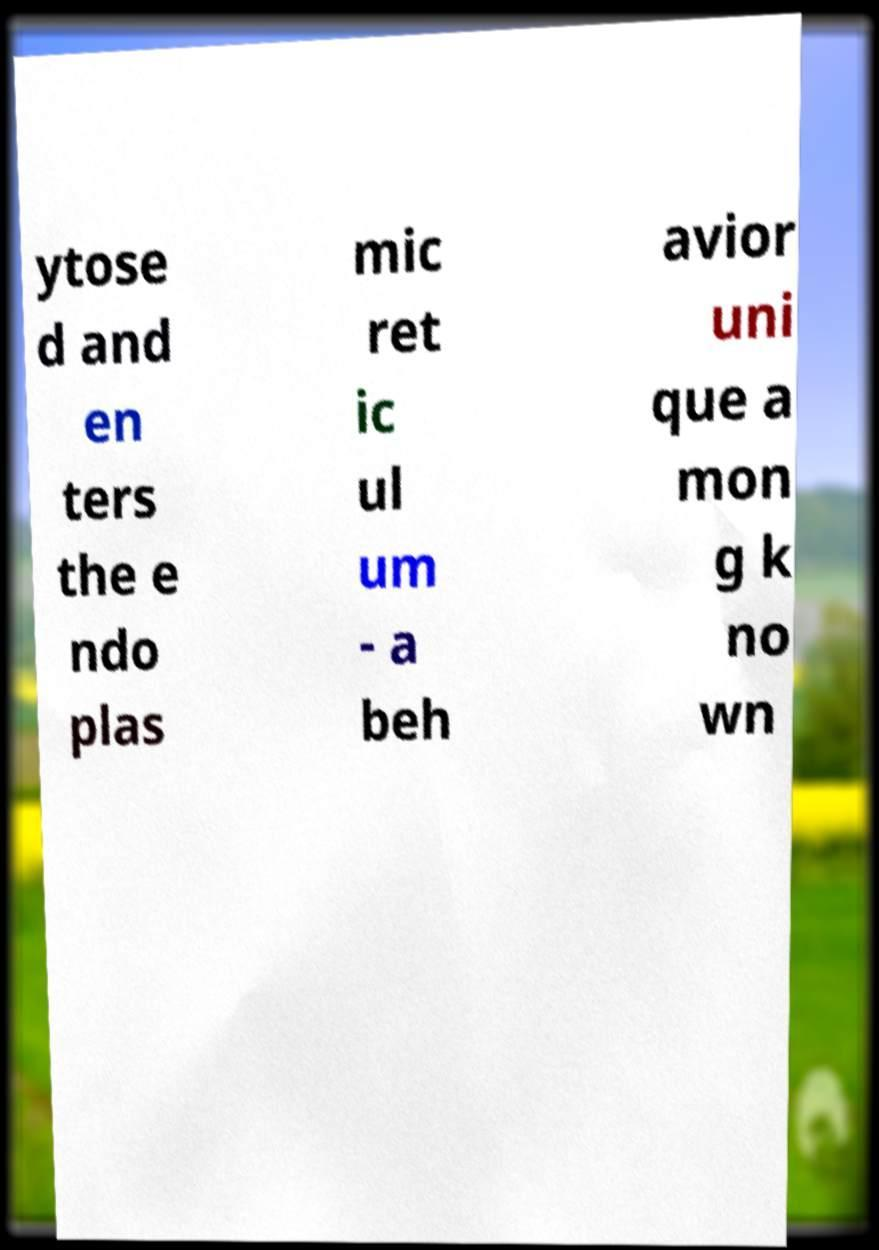For documentation purposes, I need the text within this image transcribed. Could you provide that? ytose d and en ters the e ndo plas mic ret ic ul um - a beh avior uni que a mon g k no wn 